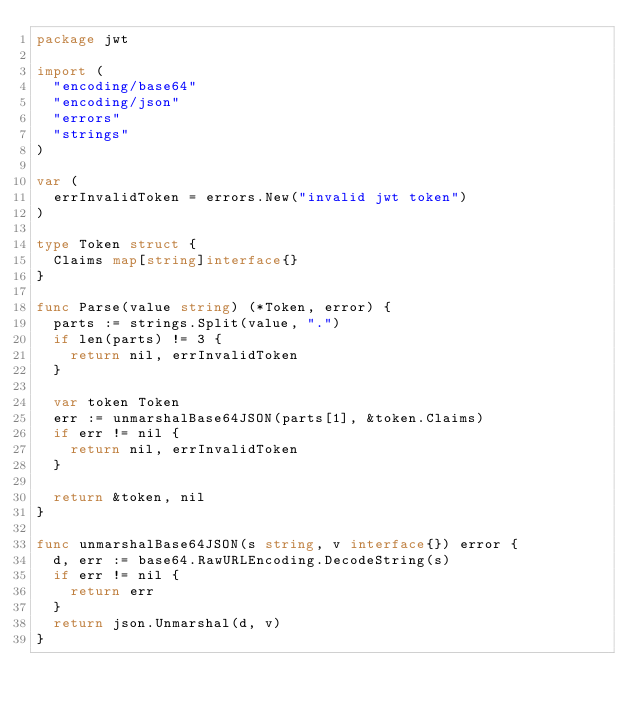Convert code to text. <code><loc_0><loc_0><loc_500><loc_500><_Go_>package jwt

import (
	"encoding/base64"
	"encoding/json"
	"errors"
	"strings"
)

var (
	errInvalidToken = errors.New("invalid jwt token")
)

type Token struct {
	Claims map[string]interface{}
}

func Parse(value string) (*Token, error) {
	parts := strings.Split(value, ".")
	if len(parts) != 3 {
		return nil, errInvalidToken
	}

	var token Token
	err := unmarshalBase64JSON(parts[1], &token.Claims)
	if err != nil {
		return nil, errInvalidToken
	}

	return &token, nil
}

func unmarshalBase64JSON(s string, v interface{}) error {
	d, err := base64.RawURLEncoding.DecodeString(s)
	if err != nil {
		return err
	}
	return json.Unmarshal(d, v)
}
</code> 